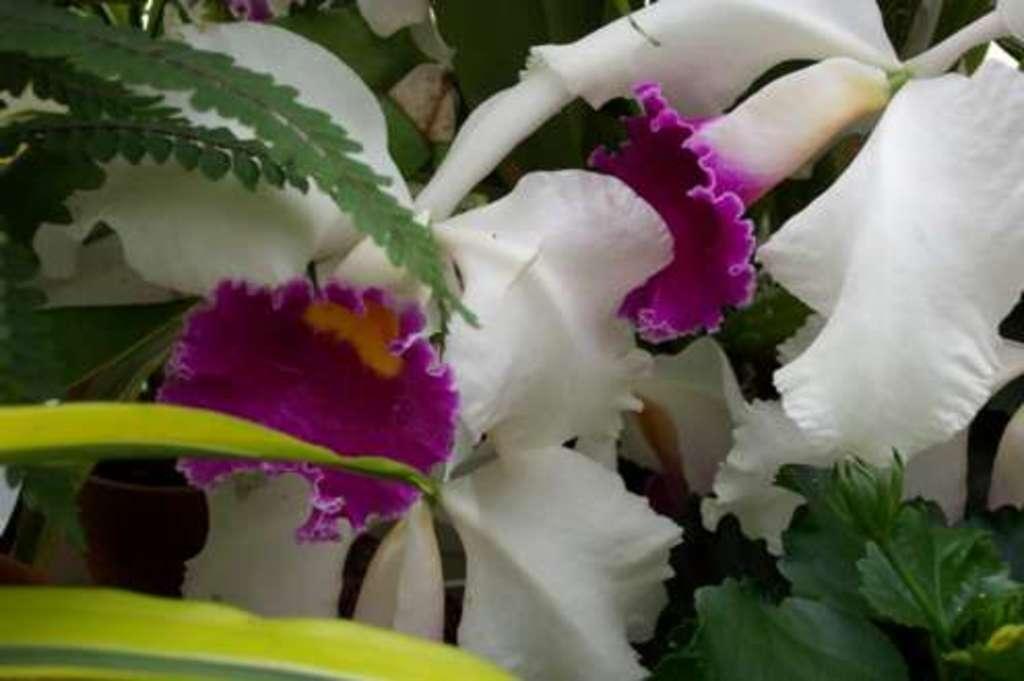How would you summarize this image in a sentence or two? In this picture we can see the flowers and leaves. 